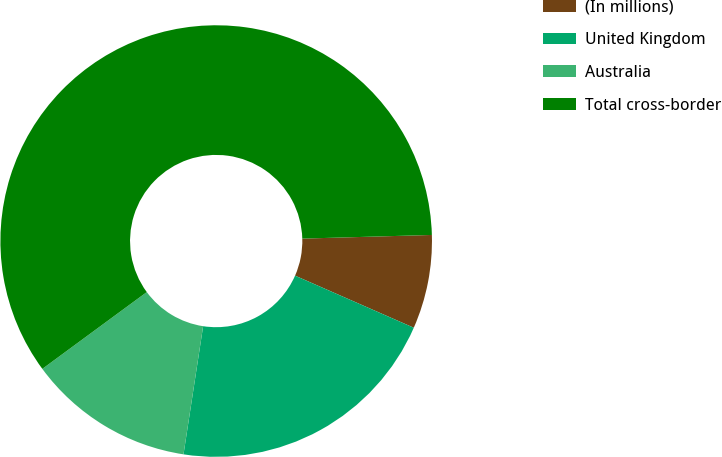<chart> <loc_0><loc_0><loc_500><loc_500><pie_chart><fcel>(In millions)<fcel>United Kingdom<fcel>Australia<fcel>Total cross-border<nl><fcel>7.03%<fcel>20.84%<fcel>12.49%<fcel>59.64%<nl></chart> 